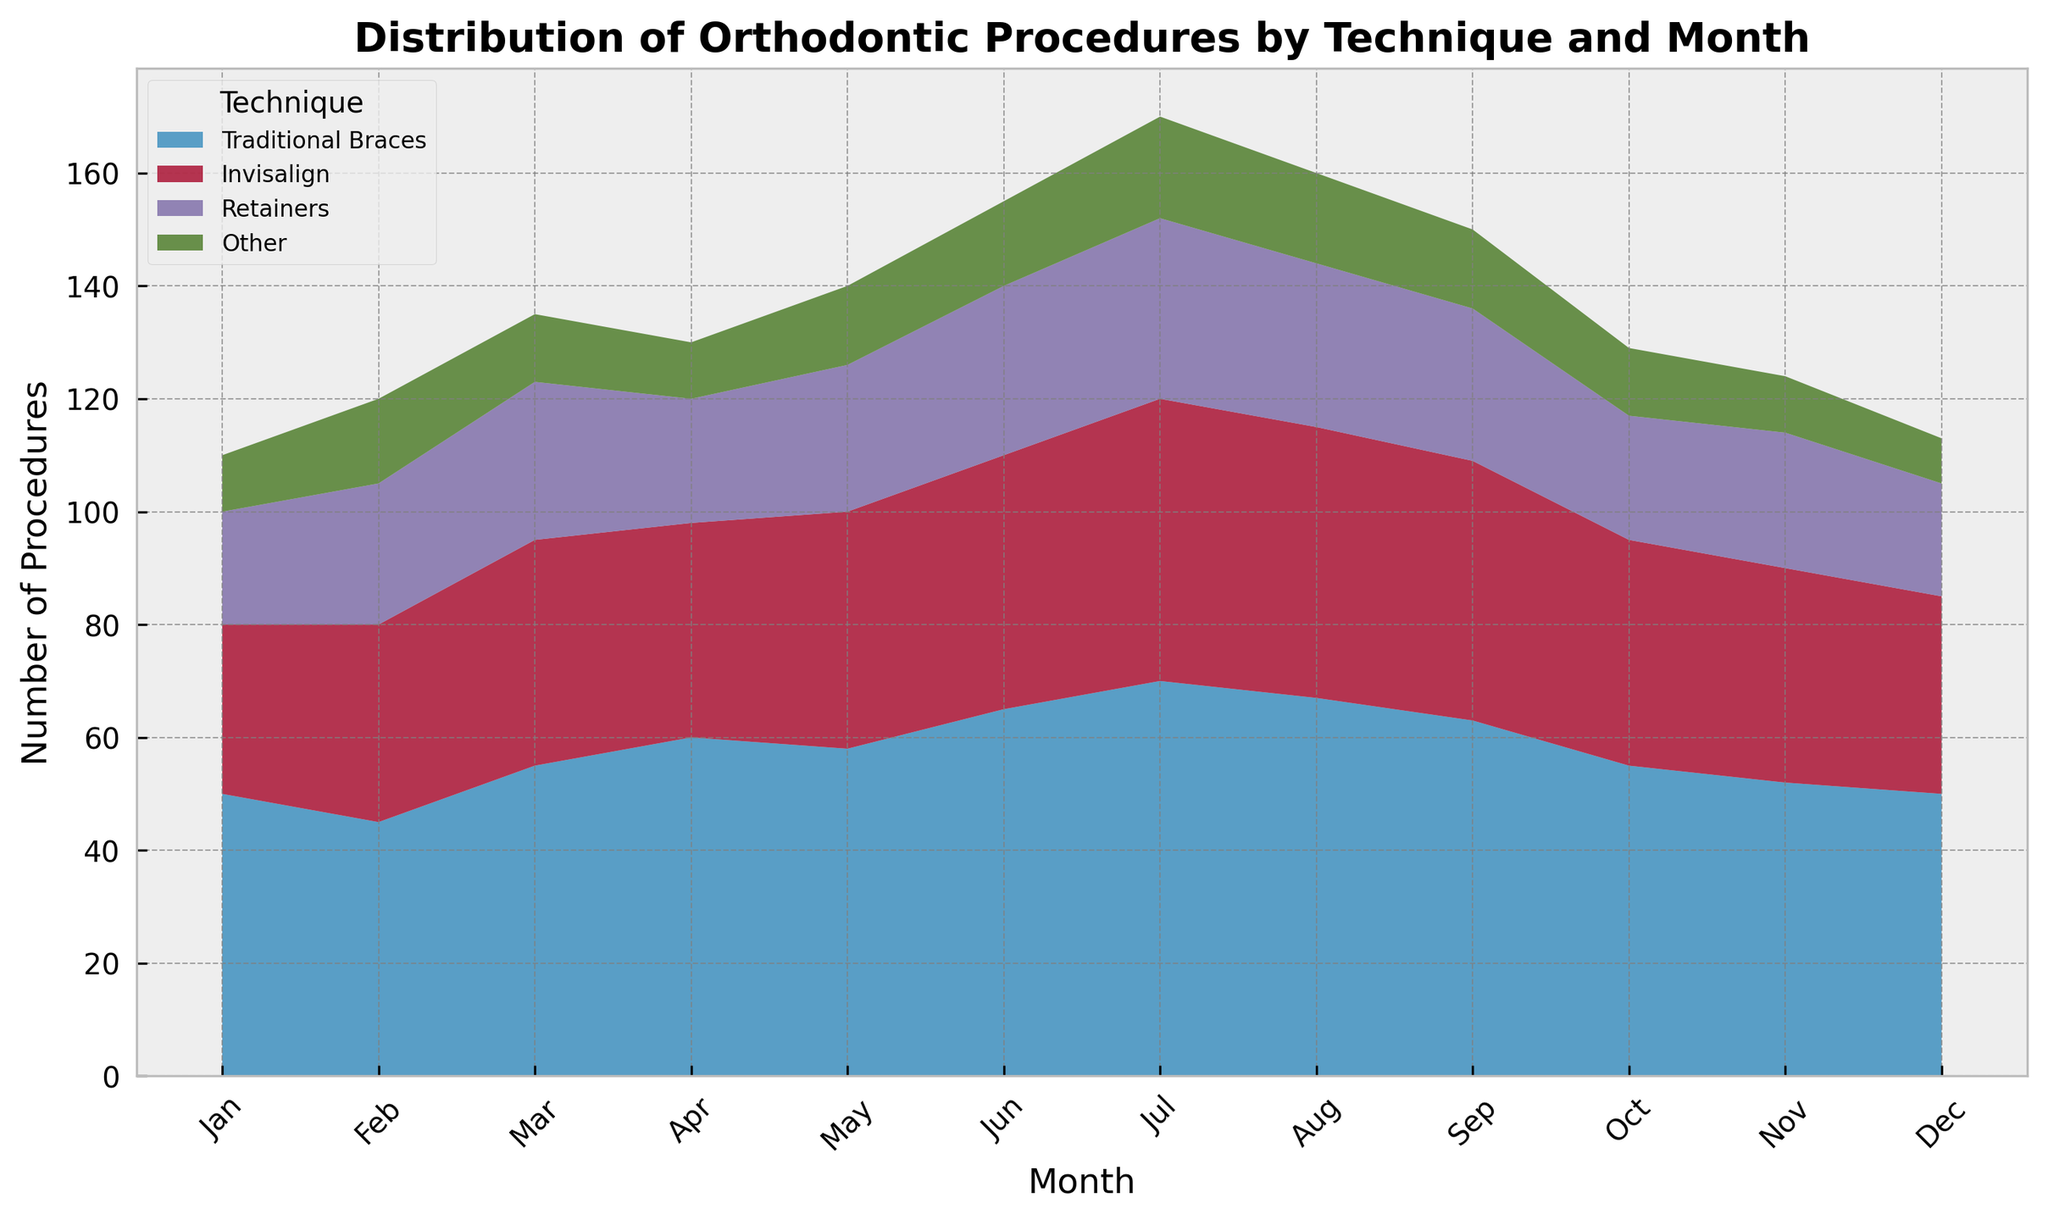What month had the highest overall number of orthodontic procedures? By examining the stack heights, the month with the highest total procedures is July. The combined height of all segments (Traditional Braces, Invisalign, Retainers, Other) is greatest in this month.
Answer: July Which orthodontic technique had the most consistent number of procedures across all months? By looking at the relative uniformity of the color bands across the months, 'Traditional Braces' has the most similar height each month, indicating consistency.
Answer: Traditional Braces During which month did 'Invisalign' surpass 'Traditional Braces' in number of procedures? By comparing the heights of the stacked areas representing 'Invisalign' and 'Traditional Braces', there is no month where 'Invisalign' exceeds 'Traditional Braces' in the number of procedures.
Answer: None What is the total number of 'Other' procedures in the first three months of the year? Sum the 'Other' values for Jan, Feb, and Mar: 10 + 15 + 12 = 37.
Answer: 37 Which month had the smallest number of 'Retainers' procedures? By identifying the shortest segments of the area chart corresponding to 'Retainers', the smallest is in December.
Answer: December In which month did 'Retainers' have the highest number of procedures? By identifying the tallest segments of the 'Retainers' area chart, the highest count is in July with 32 procedures.
Answer: July How does the number of 'Invisalign' procedures in May compare to that in August? By comparing the segment heights, in May 'Invisalign' has 42 procedures, while in August it has 48 procedures. So, August has more.
Answer: August What is the combined number of procedures for all techniques in September? Sum the values for September across all techniques: 63 (Traditional Braces) + 46 (Invisalign) + 27 (Retainers) + 14 (Other) = 150.
Answer: 150 Which technique saw the biggest increase in the number of procedures from January to June? By calculating the differences between the two months for each technique, 'Traditional Braces' saw the biggest increase from 50 to 65, which is an increase of 15.
Answer: Traditional Braces What is the average number of 'Traditional Braces' procedures over the entire year? Add the values for 'Traditional Braces' over all months: (50 + 45 + 55 + 60 + 58 + 65 + 70 + 67 + 63 + 55 + 52 + 50) and divide by 12. Total = 690 / 12 = 57.5.
Answer: 57.5 